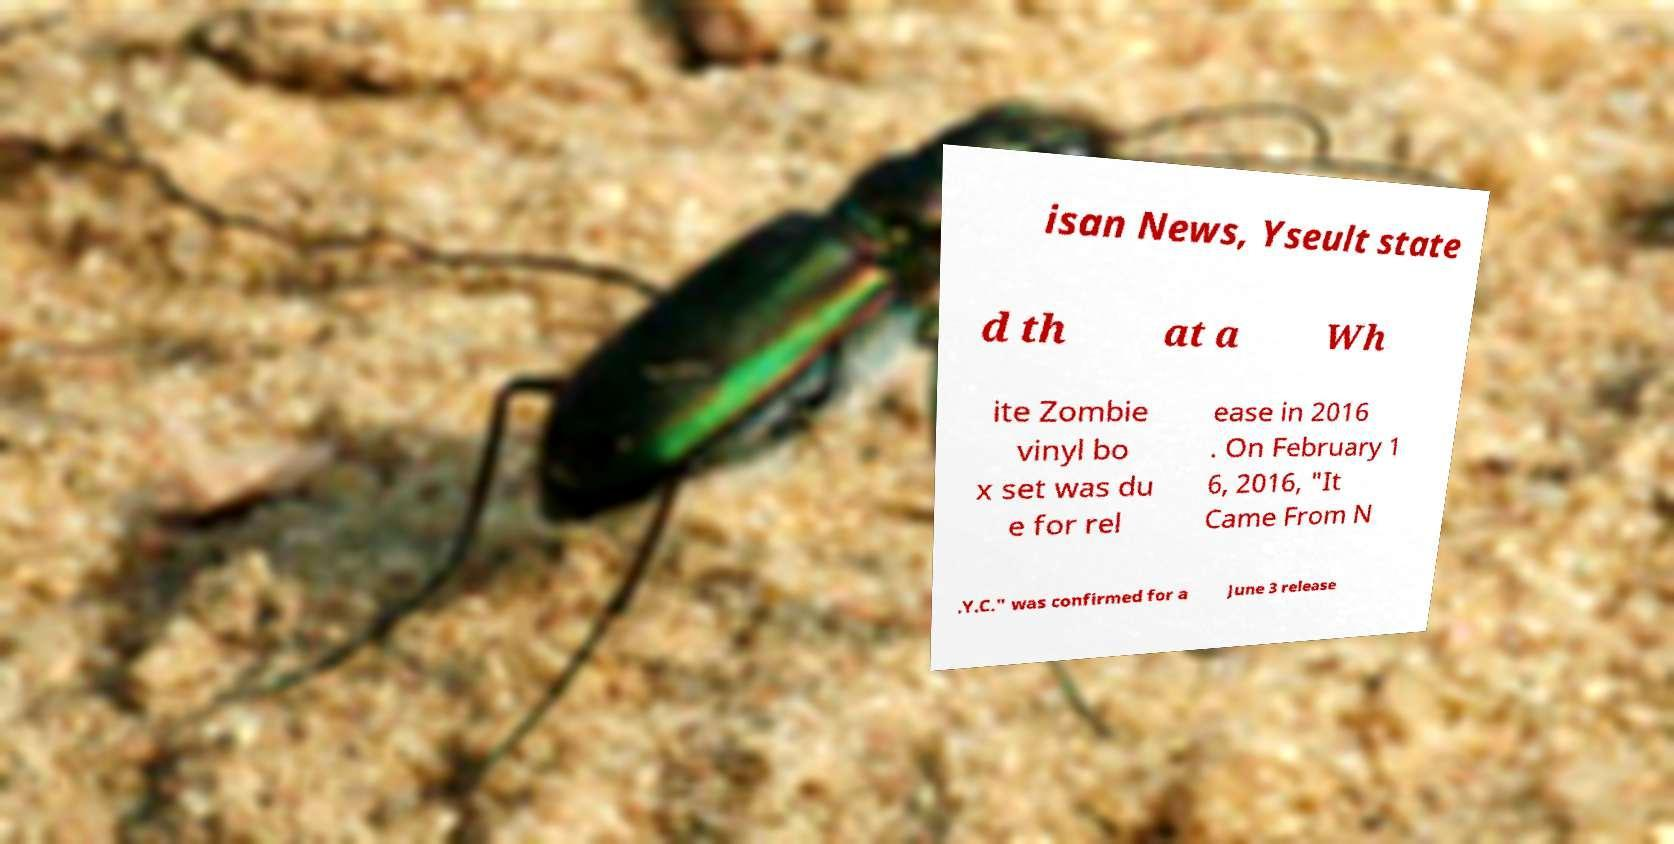For documentation purposes, I need the text within this image transcribed. Could you provide that? isan News, Yseult state d th at a Wh ite Zombie vinyl bo x set was du e for rel ease in 2016 . On February 1 6, 2016, "It Came From N .Y.C." was confirmed for a June 3 release 